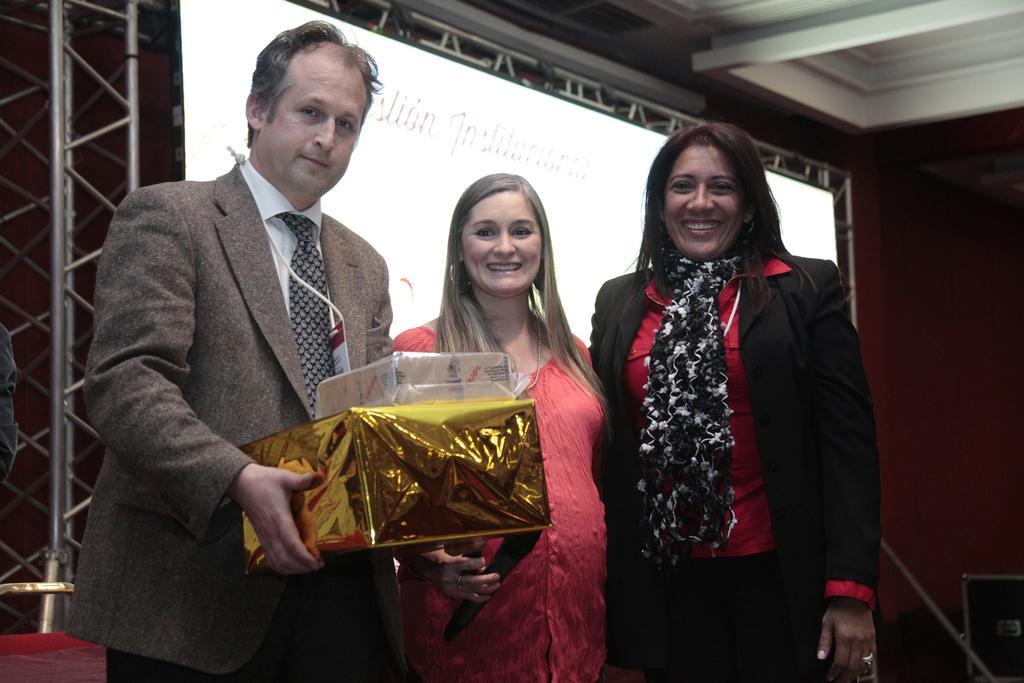Describe this image in one or two sentences. In this image we can see some people standing. And one of them is holding the gift boxes. And we can see the screen. And we can see the metal framing. 